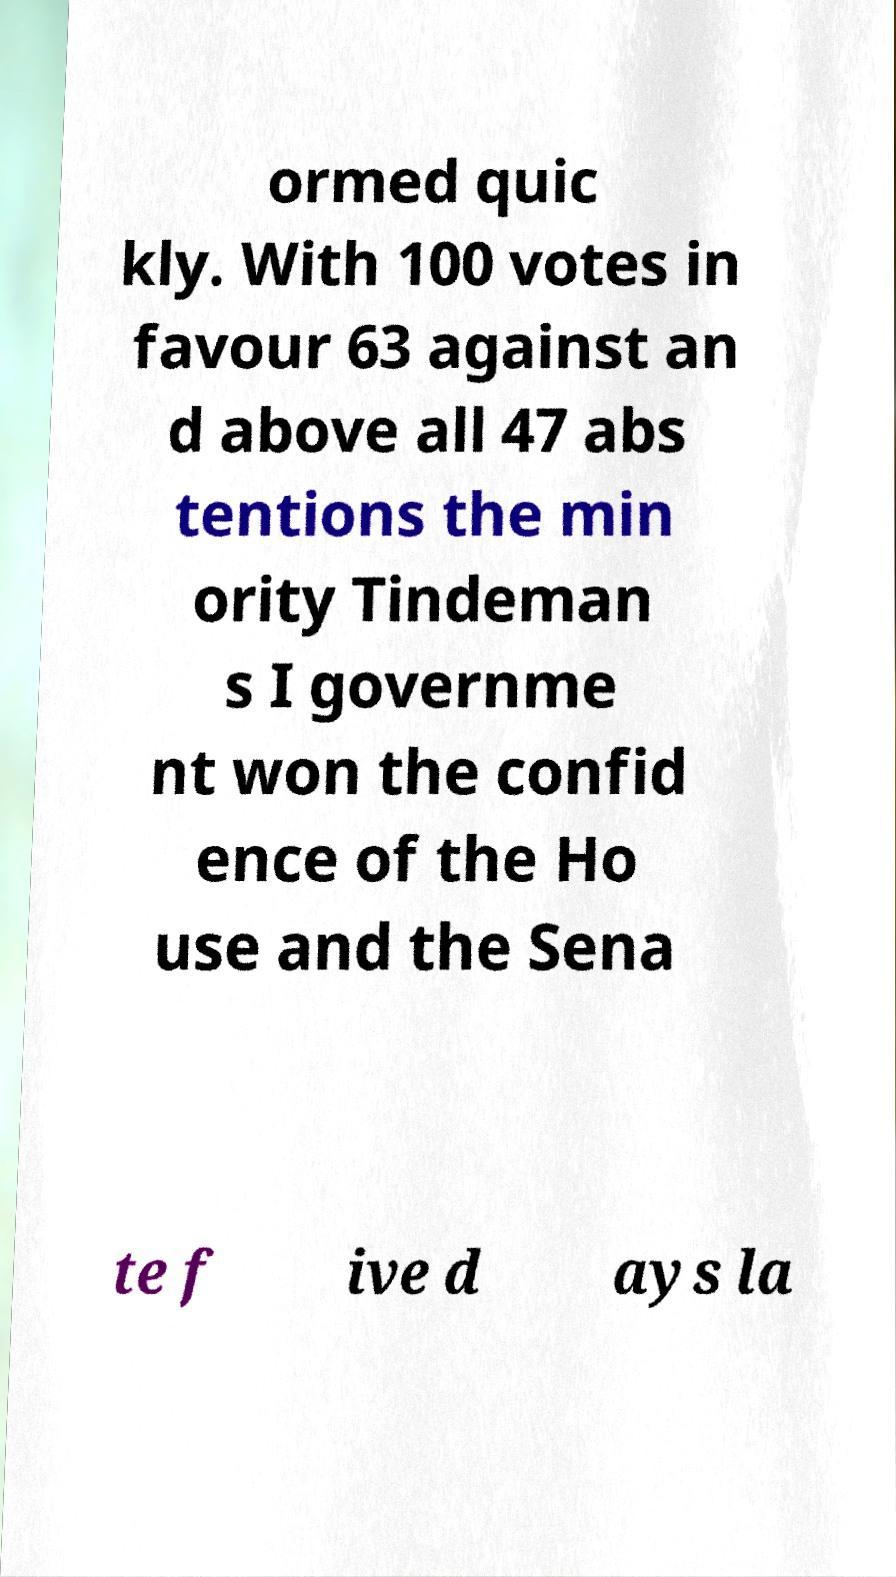Can you read and provide the text displayed in the image?This photo seems to have some interesting text. Can you extract and type it out for me? ormed quic kly. With 100 votes in favour 63 against an d above all 47 abs tentions the min ority Tindeman s I governme nt won the confid ence of the Ho use and the Sena te f ive d ays la 